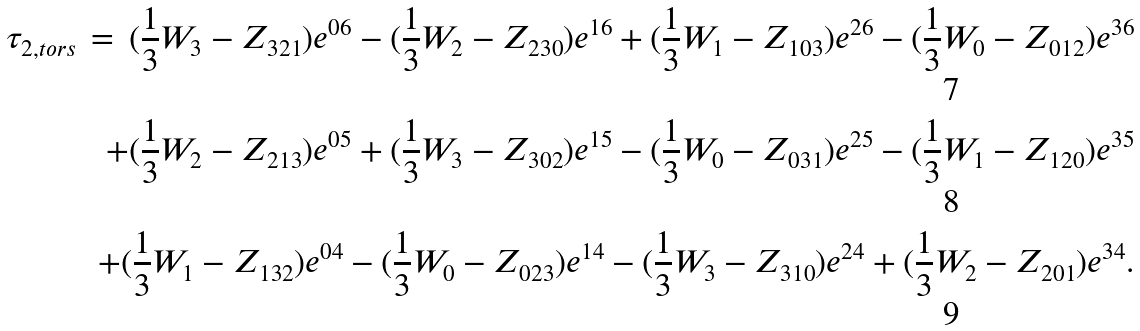<formula> <loc_0><loc_0><loc_500><loc_500>\tau _ { 2 , t o r s } \, = \, ( \frac { 1 } { 3 } W _ { 3 } - Z _ { 3 2 1 } ) e ^ { 0 6 } - ( \frac { 1 } { 3 } W _ { 2 } - Z _ { 2 3 0 } ) e ^ { 1 6 } + ( \frac { 1 } { 3 } W _ { 1 } - Z _ { 1 0 3 } ) e ^ { 2 6 } - ( \frac { 1 } { 3 } W _ { 0 } - Z _ { 0 1 2 } ) e ^ { 3 6 } \\ + ( \frac { 1 } { 3 } W _ { 2 } - Z _ { 2 1 3 } ) e ^ { 0 5 } + ( \frac { 1 } { 3 } W _ { 3 } - Z _ { 3 0 2 } ) e ^ { 1 5 } - ( \frac { 1 } { 3 } W _ { 0 } - Z _ { 0 3 1 } ) e ^ { 2 5 } - ( \frac { 1 } { 3 } W _ { 1 } - Z _ { 1 2 0 } ) e ^ { 3 5 } \\ + ( \frac { 1 } { 3 } W _ { 1 } - Z _ { 1 3 2 } ) e ^ { 0 4 } - ( \frac { 1 } { 3 } W _ { 0 } - Z _ { 0 2 3 } ) e ^ { 1 4 } - ( \frac { 1 } { 3 } W _ { 3 } - Z _ { 3 1 0 } ) e ^ { 2 4 } + ( \frac { 1 } { 3 } W _ { 2 } - Z _ { 2 0 1 } ) e ^ { 3 4 } .</formula> 